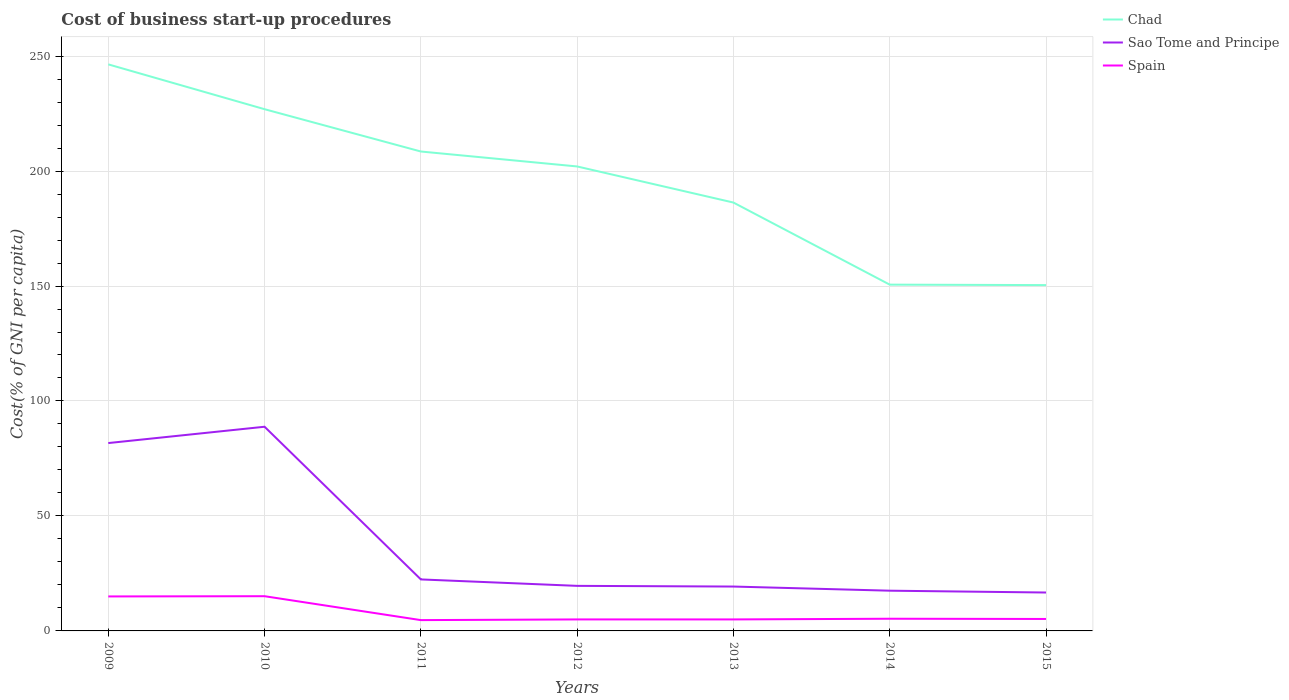What is the total cost of business start-up procedures in Chad in the graph?
Make the answer very short. 60.1. What is the difference between the highest and the second highest cost of business start-up procedures in Sao Tome and Principe?
Offer a very short reply. 72.1. What is the difference between the highest and the lowest cost of business start-up procedures in Chad?
Give a very brief answer. 4. Is the cost of business start-up procedures in Spain strictly greater than the cost of business start-up procedures in Sao Tome and Principe over the years?
Make the answer very short. Yes. What is the difference between two consecutive major ticks on the Y-axis?
Offer a very short reply. 50. Are the values on the major ticks of Y-axis written in scientific E-notation?
Offer a very short reply. No. Where does the legend appear in the graph?
Ensure brevity in your answer.  Top right. How many legend labels are there?
Provide a succinct answer. 3. How are the legend labels stacked?
Your answer should be very brief. Vertical. What is the title of the graph?
Provide a short and direct response. Cost of business start-up procedures. Does "East Asia (all income levels)" appear as one of the legend labels in the graph?
Offer a terse response. No. What is the label or title of the Y-axis?
Offer a terse response. Cost(% of GNI per capita). What is the Cost(% of GNI per capita) in Chad in 2009?
Make the answer very short. 246.4. What is the Cost(% of GNI per capita) in Sao Tome and Principe in 2009?
Your answer should be compact. 81.7. What is the Cost(% of GNI per capita) of Spain in 2009?
Offer a very short reply. 15. What is the Cost(% of GNI per capita) of Chad in 2010?
Offer a very short reply. 226.9. What is the Cost(% of GNI per capita) of Sao Tome and Principe in 2010?
Give a very brief answer. 88.8. What is the Cost(% of GNI per capita) in Chad in 2011?
Your answer should be very brief. 208.5. What is the Cost(% of GNI per capita) in Sao Tome and Principe in 2011?
Make the answer very short. 22.4. What is the Cost(% of GNI per capita) of Chad in 2012?
Offer a very short reply. 202. What is the Cost(% of GNI per capita) in Sao Tome and Principe in 2012?
Offer a terse response. 19.6. What is the Cost(% of GNI per capita) in Chad in 2013?
Keep it short and to the point. 186.3. What is the Cost(% of GNI per capita) of Sao Tome and Principe in 2013?
Ensure brevity in your answer.  19.3. What is the Cost(% of GNI per capita) in Spain in 2013?
Ensure brevity in your answer.  5. What is the Cost(% of GNI per capita) of Chad in 2014?
Offer a terse response. 150.6. What is the Cost(% of GNI per capita) in Spain in 2014?
Your answer should be very brief. 5.3. What is the Cost(% of GNI per capita) of Chad in 2015?
Your answer should be very brief. 150.4. What is the Cost(% of GNI per capita) in Sao Tome and Principe in 2015?
Offer a terse response. 16.7. Across all years, what is the maximum Cost(% of GNI per capita) in Chad?
Make the answer very short. 246.4. Across all years, what is the maximum Cost(% of GNI per capita) in Sao Tome and Principe?
Keep it short and to the point. 88.8. Across all years, what is the maximum Cost(% of GNI per capita) in Spain?
Offer a terse response. 15.1. Across all years, what is the minimum Cost(% of GNI per capita) in Chad?
Keep it short and to the point. 150.4. Across all years, what is the minimum Cost(% of GNI per capita) of Spain?
Keep it short and to the point. 4.7. What is the total Cost(% of GNI per capita) in Chad in the graph?
Provide a succinct answer. 1371.1. What is the total Cost(% of GNI per capita) in Sao Tome and Principe in the graph?
Make the answer very short. 266. What is the total Cost(% of GNI per capita) of Spain in the graph?
Give a very brief answer. 55.3. What is the difference between the Cost(% of GNI per capita) in Chad in 2009 and that in 2010?
Your answer should be compact. 19.5. What is the difference between the Cost(% of GNI per capita) of Sao Tome and Principe in 2009 and that in 2010?
Your response must be concise. -7.1. What is the difference between the Cost(% of GNI per capita) of Spain in 2009 and that in 2010?
Offer a very short reply. -0.1. What is the difference between the Cost(% of GNI per capita) of Chad in 2009 and that in 2011?
Your answer should be very brief. 37.9. What is the difference between the Cost(% of GNI per capita) in Sao Tome and Principe in 2009 and that in 2011?
Give a very brief answer. 59.3. What is the difference between the Cost(% of GNI per capita) of Spain in 2009 and that in 2011?
Ensure brevity in your answer.  10.3. What is the difference between the Cost(% of GNI per capita) of Chad in 2009 and that in 2012?
Provide a succinct answer. 44.4. What is the difference between the Cost(% of GNI per capita) in Sao Tome and Principe in 2009 and that in 2012?
Your response must be concise. 62.1. What is the difference between the Cost(% of GNI per capita) in Chad in 2009 and that in 2013?
Your answer should be very brief. 60.1. What is the difference between the Cost(% of GNI per capita) in Sao Tome and Principe in 2009 and that in 2013?
Offer a very short reply. 62.4. What is the difference between the Cost(% of GNI per capita) of Chad in 2009 and that in 2014?
Provide a short and direct response. 95.8. What is the difference between the Cost(% of GNI per capita) of Sao Tome and Principe in 2009 and that in 2014?
Your response must be concise. 64.2. What is the difference between the Cost(% of GNI per capita) of Chad in 2009 and that in 2015?
Offer a very short reply. 96. What is the difference between the Cost(% of GNI per capita) of Chad in 2010 and that in 2011?
Keep it short and to the point. 18.4. What is the difference between the Cost(% of GNI per capita) in Sao Tome and Principe in 2010 and that in 2011?
Give a very brief answer. 66.4. What is the difference between the Cost(% of GNI per capita) in Spain in 2010 and that in 2011?
Your response must be concise. 10.4. What is the difference between the Cost(% of GNI per capita) of Chad in 2010 and that in 2012?
Your answer should be compact. 24.9. What is the difference between the Cost(% of GNI per capita) in Sao Tome and Principe in 2010 and that in 2012?
Offer a terse response. 69.2. What is the difference between the Cost(% of GNI per capita) in Spain in 2010 and that in 2012?
Provide a short and direct response. 10.1. What is the difference between the Cost(% of GNI per capita) in Chad in 2010 and that in 2013?
Give a very brief answer. 40.6. What is the difference between the Cost(% of GNI per capita) of Sao Tome and Principe in 2010 and that in 2013?
Offer a terse response. 69.5. What is the difference between the Cost(% of GNI per capita) of Spain in 2010 and that in 2013?
Give a very brief answer. 10.1. What is the difference between the Cost(% of GNI per capita) of Chad in 2010 and that in 2014?
Offer a very short reply. 76.3. What is the difference between the Cost(% of GNI per capita) in Sao Tome and Principe in 2010 and that in 2014?
Provide a succinct answer. 71.3. What is the difference between the Cost(% of GNI per capita) of Chad in 2010 and that in 2015?
Your response must be concise. 76.5. What is the difference between the Cost(% of GNI per capita) in Sao Tome and Principe in 2010 and that in 2015?
Give a very brief answer. 72.1. What is the difference between the Cost(% of GNI per capita) in Spain in 2011 and that in 2012?
Your answer should be compact. -0.3. What is the difference between the Cost(% of GNI per capita) of Sao Tome and Principe in 2011 and that in 2013?
Offer a very short reply. 3.1. What is the difference between the Cost(% of GNI per capita) in Spain in 2011 and that in 2013?
Make the answer very short. -0.3. What is the difference between the Cost(% of GNI per capita) in Chad in 2011 and that in 2014?
Offer a very short reply. 57.9. What is the difference between the Cost(% of GNI per capita) of Spain in 2011 and that in 2014?
Provide a succinct answer. -0.6. What is the difference between the Cost(% of GNI per capita) in Chad in 2011 and that in 2015?
Ensure brevity in your answer.  58.1. What is the difference between the Cost(% of GNI per capita) of Sao Tome and Principe in 2011 and that in 2015?
Offer a terse response. 5.7. What is the difference between the Cost(% of GNI per capita) in Spain in 2011 and that in 2015?
Give a very brief answer. -0.5. What is the difference between the Cost(% of GNI per capita) in Spain in 2012 and that in 2013?
Offer a very short reply. 0. What is the difference between the Cost(% of GNI per capita) in Chad in 2012 and that in 2014?
Provide a short and direct response. 51.4. What is the difference between the Cost(% of GNI per capita) in Sao Tome and Principe in 2012 and that in 2014?
Provide a succinct answer. 2.1. What is the difference between the Cost(% of GNI per capita) in Spain in 2012 and that in 2014?
Give a very brief answer. -0.3. What is the difference between the Cost(% of GNI per capita) of Chad in 2012 and that in 2015?
Your response must be concise. 51.6. What is the difference between the Cost(% of GNI per capita) in Sao Tome and Principe in 2012 and that in 2015?
Make the answer very short. 2.9. What is the difference between the Cost(% of GNI per capita) in Spain in 2012 and that in 2015?
Ensure brevity in your answer.  -0.2. What is the difference between the Cost(% of GNI per capita) of Chad in 2013 and that in 2014?
Your response must be concise. 35.7. What is the difference between the Cost(% of GNI per capita) in Sao Tome and Principe in 2013 and that in 2014?
Keep it short and to the point. 1.8. What is the difference between the Cost(% of GNI per capita) in Spain in 2013 and that in 2014?
Keep it short and to the point. -0.3. What is the difference between the Cost(% of GNI per capita) of Chad in 2013 and that in 2015?
Your answer should be very brief. 35.9. What is the difference between the Cost(% of GNI per capita) of Sao Tome and Principe in 2013 and that in 2015?
Offer a terse response. 2.6. What is the difference between the Cost(% of GNI per capita) in Spain in 2013 and that in 2015?
Your answer should be compact. -0.2. What is the difference between the Cost(% of GNI per capita) in Spain in 2014 and that in 2015?
Your response must be concise. 0.1. What is the difference between the Cost(% of GNI per capita) in Chad in 2009 and the Cost(% of GNI per capita) in Sao Tome and Principe in 2010?
Your response must be concise. 157.6. What is the difference between the Cost(% of GNI per capita) of Chad in 2009 and the Cost(% of GNI per capita) of Spain in 2010?
Ensure brevity in your answer.  231.3. What is the difference between the Cost(% of GNI per capita) of Sao Tome and Principe in 2009 and the Cost(% of GNI per capita) of Spain in 2010?
Give a very brief answer. 66.6. What is the difference between the Cost(% of GNI per capita) of Chad in 2009 and the Cost(% of GNI per capita) of Sao Tome and Principe in 2011?
Your answer should be very brief. 224. What is the difference between the Cost(% of GNI per capita) in Chad in 2009 and the Cost(% of GNI per capita) in Spain in 2011?
Ensure brevity in your answer.  241.7. What is the difference between the Cost(% of GNI per capita) in Chad in 2009 and the Cost(% of GNI per capita) in Sao Tome and Principe in 2012?
Your answer should be compact. 226.8. What is the difference between the Cost(% of GNI per capita) of Chad in 2009 and the Cost(% of GNI per capita) of Spain in 2012?
Provide a short and direct response. 241.4. What is the difference between the Cost(% of GNI per capita) of Sao Tome and Principe in 2009 and the Cost(% of GNI per capita) of Spain in 2012?
Offer a terse response. 76.7. What is the difference between the Cost(% of GNI per capita) in Chad in 2009 and the Cost(% of GNI per capita) in Sao Tome and Principe in 2013?
Make the answer very short. 227.1. What is the difference between the Cost(% of GNI per capita) of Chad in 2009 and the Cost(% of GNI per capita) of Spain in 2013?
Your response must be concise. 241.4. What is the difference between the Cost(% of GNI per capita) of Sao Tome and Principe in 2009 and the Cost(% of GNI per capita) of Spain in 2013?
Provide a short and direct response. 76.7. What is the difference between the Cost(% of GNI per capita) in Chad in 2009 and the Cost(% of GNI per capita) in Sao Tome and Principe in 2014?
Ensure brevity in your answer.  228.9. What is the difference between the Cost(% of GNI per capita) in Chad in 2009 and the Cost(% of GNI per capita) in Spain in 2014?
Offer a terse response. 241.1. What is the difference between the Cost(% of GNI per capita) of Sao Tome and Principe in 2009 and the Cost(% of GNI per capita) of Spain in 2014?
Provide a succinct answer. 76.4. What is the difference between the Cost(% of GNI per capita) of Chad in 2009 and the Cost(% of GNI per capita) of Sao Tome and Principe in 2015?
Your answer should be very brief. 229.7. What is the difference between the Cost(% of GNI per capita) of Chad in 2009 and the Cost(% of GNI per capita) of Spain in 2015?
Your response must be concise. 241.2. What is the difference between the Cost(% of GNI per capita) of Sao Tome and Principe in 2009 and the Cost(% of GNI per capita) of Spain in 2015?
Ensure brevity in your answer.  76.5. What is the difference between the Cost(% of GNI per capita) of Chad in 2010 and the Cost(% of GNI per capita) of Sao Tome and Principe in 2011?
Your answer should be very brief. 204.5. What is the difference between the Cost(% of GNI per capita) of Chad in 2010 and the Cost(% of GNI per capita) of Spain in 2011?
Keep it short and to the point. 222.2. What is the difference between the Cost(% of GNI per capita) in Sao Tome and Principe in 2010 and the Cost(% of GNI per capita) in Spain in 2011?
Your answer should be compact. 84.1. What is the difference between the Cost(% of GNI per capita) of Chad in 2010 and the Cost(% of GNI per capita) of Sao Tome and Principe in 2012?
Ensure brevity in your answer.  207.3. What is the difference between the Cost(% of GNI per capita) in Chad in 2010 and the Cost(% of GNI per capita) in Spain in 2012?
Your response must be concise. 221.9. What is the difference between the Cost(% of GNI per capita) in Sao Tome and Principe in 2010 and the Cost(% of GNI per capita) in Spain in 2012?
Provide a short and direct response. 83.8. What is the difference between the Cost(% of GNI per capita) in Chad in 2010 and the Cost(% of GNI per capita) in Sao Tome and Principe in 2013?
Your answer should be very brief. 207.6. What is the difference between the Cost(% of GNI per capita) in Chad in 2010 and the Cost(% of GNI per capita) in Spain in 2013?
Provide a short and direct response. 221.9. What is the difference between the Cost(% of GNI per capita) in Sao Tome and Principe in 2010 and the Cost(% of GNI per capita) in Spain in 2013?
Make the answer very short. 83.8. What is the difference between the Cost(% of GNI per capita) of Chad in 2010 and the Cost(% of GNI per capita) of Sao Tome and Principe in 2014?
Offer a terse response. 209.4. What is the difference between the Cost(% of GNI per capita) in Chad in 2010 and the Cost(% of GNI per capita) in Spain in 2014?
Offer a very short reply. 221.6. What is the difference between the Cost(% of GNI per capita) in Sao Tome and Principe in 2010 and the Cost(% of GNI per capita) in Spain in 2014?
Give a very brief answer. 83.5. What is the difference between the Cost(% of GNI per capita) of Chad in 2010 and the Cost(% of GNI per capita) of Sao Tome and Principe in 2015?
Provide a succinct answer. 210.2. What is the difference between the Cost(% of GNI per capita) in Chad in 2010 and the Cost(% of GNI per capita) in Spain in 2015?
Make the answer very short. 221.7. What is the difference between the Cost(% of GNI per capita) of Sao Tome and Principe in 2010 and the Cost(% of GNI per capita) of Spain in 2015?
Give a very brief answer. 83.6. What is the difference between the Cost(% of GNI per capita) of Chad in 2011 and the Cost(% of GNI per capita) of Sao Tome and Principe in 2012?
Give a very brief answer. 188.9. What is the difference between the Cost(% of GNI per capita) of Chad in 2011 and the Cost(% of GNI per capita) of Spain in 2012?
Give a very brief answer. 203.5. What is the difference between the Cost(% of GNI per capita) in Chad in 2011 and the Cost(% of GNI per capita) in Sao Tome and Principe in 2013?
Provide a succinct answer. 189.2. What is the difference between the Cost(% of GNI per capita) of Chad in 2011 and the Cost(% of GNI per capita) of Spain in 2013?
Make the answer very short. 203.5. What is the difference between the Cost(% of GNI per capita) in Chad in 2011 and the Cost(% of GNI per capita) in Sao Tome and Principe in 2014?
Provide a succinct answer. 191. What is the difference between the Cost(% of GNI per capita) of Chad in 2011 and the Cost(% of GNI per capita) of Spain in 2014?
Give a very brief answer. 203.2. What is the difference between the Cost(% of GNI per capita) in Chad in 2011 and the Cost(% of GNI per capita) in Sao Tome and Principe in 2015?
Your answer should be very brief. 191.8. What is the difference between the Cost(% of GNI per capita) of Chad in 2011 and the Cost(% of GNI per capita) of Spain in 2015?
Make the answer very short. 203.3. What is the difference between the Cost(% of GNI per capita) of Sao Tome and Principe in 2011 and the Cost(% of GNI per capita) of Spain in 2015?
Provide a short and direct response. 17.2. What is the difference between the Cost(% of GNI per capita) in Chad in 2012 and the Cost(% of GNI per capita) in Sao Tome and Principe in 2013?
Make the answer very short. 182.7. What is the difference between the Cost(% of GNI per capita) of Chad in 2012 and the Cost(% of GNI per capita) of Spain in 2013?
Your answer should be compact. 197. What is the difference between the Cost(% of GNI per capita) in Sao Tome and Principe in 2012 and the Cost(% of GNI per capita) in Spain in 2013?
Keep it short and to the point. 14.6. What is the difference between the Cost(% of GNI per capita) in Chad in 2012 and the Cost(% of GNI per capita) in Sao Tome and Principe in 2014?
Offer a very short reply. 184.5. What is the difference between the Cost(% of GNI per capita) of Chad in 2012 and the Cost(% of GNI per capita) of Spain in 2014?
Provide a short and direct response. 196.7. What is the difference between the Cost(% of GNI per capita) of Sao Tome and Principe in 2012 and the Cost(% of GNI per capita) of Spain in 2014?
Your response must be concise. 14.3. What is the difference between the Cost(% of GNI per capita) of Chad in 2012 and the Cost(% of GNI per capita) of Sao Tome and Principe in 2015?
Your response must be concise. 185.3. What is the difference between the Cost(% of GNI per capita) in Chad in 2012 and the Cost(% of GNI per capita) in Spain in 2015?
Ensure brevity in your answer.  196.8. What is the difference between the Cost(% of GNI per capita) in Sao Tome and Principe in 2012 and the Cost(% of GNI per capita) in Spain in 2015?
Keep it short and to the point. 14.4. What is the difference between the Cost(% of GNI per capita) in Chad in 2013 and the Cost(% of GNI per capita) in Sao Tome and Principe in 2014?
Your answer should be very brief. 168.8. What is the difference between the Cost(% of GNI per capita) of Chad in 2013 and the Cost(% of GNI per capita) of Spain in 2014?
Offer a terse response. 181. What is the difference between the Cost(% of GNI per capita) of Sao Tome and Principe in 2013 and the Cost(% of GNI per capita) of Spain in 2014?
Provide a succinct answer. 14. What is the difference between the Cost(% of GNI per capita) of Chad in 2013 and the Cost(% of GNI per capita) of Sao Tome and Principe in 2015?
Your answer should be very brief. 169.6. What is the difference between the Cost(% of GNI per capita) in Chad in 2013 and the Cost(% of GNI per capita) in Spain in 2015?
Keep it short and to the point. 181.1. What is the difference between the Cost(% of GNI per capita) of Chad in 2014 and the Cost(% of GNI per capita) of Sao Tome and Principe in 2015?
Offer a very short reply. 133.9. What is the difference between the Cost(% of GNI per capita) in Chad in 2014 and the Cost(% of GNI per capita) in Spain in 2015?
Provide a short and direct response. 145.4. What is the difference between the Cost(% of GNI per capita) of Sao Tome and Principe in 2014 and the Cost(% of GNI per capita) of Spain in 2015?
Provide a succinct answer. 12.3. What is the average Cost(% of GNI per capita) in Chad per year?
Keep it short and to the point. 195.87. What is the average Cost(% of GNI per capita) in Sao Tome and Principe per year?
Make the answer very short. 38. In the year 2009, what is the difference between the Cost(% of GNI per capita) of Chad and Cost(% of GNI per capita) of Sao Tome and Principe?
Make the answer very short. 164.7. In the year 2009, what is the difference between the Cost(% of GNI per capita) in Chad and Cost(% of GNI per capita) in Spain?
Offer a very short reply. 231.4. In the year 2009, what is the difference between the Cost(% of GNI per capita) of Sao Tome and Principe and Cost(% of GNI per capita) of Spain?
Offer a terse response. 66.7. In the year 2010, what is the difference between the Cost(% of GNI per capita) in Chad and Cost(% of GNI per capita) in Sao Tome and Principe?
Your answer should be very brief. 138.1. In the year 2010, what is the difference between the Cost(% of GNI per capita) in Chad and Cost(% of GNI per capita) in Spain?
Provide a succinct answer. 211.8. In the year 2010, what is the difference between the Cost(% of GNI per capita) of Sao Tome and Principe and Cost(% of GNI per capita) of Spain?
Ensure brevity in your answer.  73.7. In the year 2011, what is the difference between the Cost(% of GNI per capita) of Chad and Cost(% of GNI per capita) of Sao Tome and Principe?
Your response must be concise. 186.1. In the year 2011, what is the difference between the Cost(% of GNI per capita) of Chad and Cost(% of GNI per capita) of Spain?
Your response must be concise. 203.8. In the year 2011, what is the difference between the Cost(% of GNI per capita) in Sao Tome and Principe and Cost(% of GNI per capita) in Spain?
Ensure brevity in your answer.  17.7. In the year 2012, what is the difference between the Cost(% of GNI per capita) of Chad and Cost(% of GNI per capita) of Sao Tome and Principe?
Give a very brief answer. 182.4. In the year 2012, what is the difference between the Cost(% of GNI per capita) in Chad and Cost(% of GNI per capita) in Spain?
Your answer should be very brief. 197. In the year 2012, what is the difference between the Cost(% of GNI per capita) in Sao Tome and Principe and Cost(% of GNI per capita) in Spain?
Offer a terse response. 14.6. In the year 2013, what is the difference between the Cost(% of GNI per capita) in Chad and Cost(% of GNI per capita) in Sao Tome and Principe?
Offer a terse response. 167. In the year 2013, what is the difference between the Cost(% of GNI per capita) of Chad and Cost(% of GNI per capita) of Spain?
Offer a terse response. 181.3. In the year 2013, what is the difference between the Cost(% of GNI per capita) of Sao Tome and Principe and Cost(% of GNI per capita) of Spain?
Offer a very short reply. 14.3. In the year 2014, what is the difference between the Cost(% of GNI per capita) in Chad and Cost(% of GNI per capita) in Sao Tome and Principe?
Provide a short and direct response. 133.1. In the year 2014, what is the difference between the Cost(% of GNI per capita) in Chad and Cost(% of GNI per capita) in Spain?
Ensure brevity in your answer.  145.3. In the year 2015, what is the difference between the Cost(% of GNI per capita) of Chad and Cost(% of GNI per capita) of Sao Tome and Principe?
Provide a succinct answer. 133.7. In the year 2015, what is the difference between the Cost(% of GNI per capita) in Chad and Cost(% of GNI per capita) in Spain?
Give a very brief answer. 145.2. In the year 2015, what is the difference between the Cost(% of GNI per capita) in Sao Tome and Principe and Cost(% of GNI per capita) in Spain?
Offer a terse response. 11.5. What is the ratio of the Cost(% of GNI per capita) in Chad in 2009 to that in 2010?
Ensure brevity in your answer.  1.09. What is the ratio of the Cost(% of GNI per capita) of Chad in 2009 to that in 2011?
Keep it short and to the point. 1.18. What is the ratio of the Cost(% of GNI per capita) of Sao Tome and Principe in 2009 to that in 2011?
Your answer should be compact. 3.65. What is the ratio of the Cost(% of GNI per capita) in Spain in 2009 to that in 2011?
Provide a short and direct response. 3.19. What is the ratio of the Cost(% of GNI per capita) of Chad in 2009 to that in 2012?
Offer a very short reply. 1.22. What is the ratio of the Cost(% of GNI per capita) of Sao Tome and Principe in 2009 to that in 2012?
Provide a short and direct response. 4.17. What is the ratio of the Cost(% of GNI per capita) of Spain in 2009 to that in 2012?
Offer a very short reply. 3. What is the ratio of the Cost(% of GNI per capita) of Chad in 2009 to that in 2013?
Provide a short and direct response. 1.32. What is the ratio of the Cost(% of GNI per capita) in Sao Tome and Principe in 2009 to that in 2013?
Offer a very short reply. 4.23. What is the ratio of the Cost(% of GNI per capita) in Chad in 2009 to that in 2014?
Your answer should be very brief. 1.64. What is the ratio of the Cost(% of GNI per capita) in Sao Tome and Principe in 2009 to that in 2014?
Keep it short and to the point. 4.67. What is the ratio of the Cost(% of GNI per capita) in Spain in 2009 to that in 2014?
Your answer should be very brief. 2.83. What is the ratio of the Cost(% of GNI per capita) in Chad in 2009 to that in 2015?
Your answer should be compact. 1.64. What is the ratio of the Cost(% of GNI per capita) in Sao Tome and Principe in 2009 to that in 2015?
Give a very brief answer. 4.89. What is the ratio of the Cost(% of GNI per capita) in Spain in 2009 to that in 2015?
Your response must be concise. 2.88. What is the ratio of the Cost(% of GNI per capita) of Chad in 2010 to that in 2011?
Offer a terse response. 1.09. What is the ratio of the Cost(% of GNI per capita) in Sao Tome and Principe in 2010 to that in 2011?
Keep it short and to the point. 3.96. What is the ratio of the Cost(% of GNI per capita) in Spain in 2010 to that in 2011?
Your answer should be very brief. 3.21. What is the ratio of the Cost(% of GNI per capita) in Chad in 2010 to that in 2012?
Keep it short and to the point. 1.12. What is the ratio of the Cost(% of GNI per capita) in Sao Tome and Principe in 2010 to that in 2012?
Offer a very short reply. 4.53. What is the ratio of the Cost(% of GNI per capita) in Spain in 2010 to that in 2012?
Offer a very short reply. 3.02. What is the ratio of the Cost(% of GNI per capita) in Chad in 2010 to that in 2013?
Offer a terse response. 1.22. What is the ratio of the Cost(% of GNI per capita) of Sao Tome and Principe in 2010 to that in 2013?
Provide a succinct answer. 4.6. What is the ratio of the Cost(% of GNI per capita) of Spain in 2010 to that in 2013?
Give a very brief answer. 3.02. What is the ratio of the Cost(% of GNI per capita) of Chad in 2010 to that in 2014?
Your answer should be very brief. 1.51. What is the ratio of the Cost(% of GNI per capita) of Sao Tome and Principe in 2010 to that in 2014?
Provide a succinct answer. 5.07. What is the ratio of the Cost(% of GNI per capita) in Spain in 2010 to that in 2014?
Offer a terse response. 2.85. What is the ratio of the Cost(% of GNI per capita) of Chad in 2010 to that in 2015?
Your response must be concise. 1.51. What is the ratio of the Cost(% of GNI per capita) in Sao Tome and Principe in 2010 to that in 2015?
Make the answer very short. 5.32. What is the ratio of the Cost(% of GNI per capita) of Spain in 2010 to that in 2015?
Your response must be concise. 2.9. What is the ratio of the Cost(% of GNI per capita) in Chad in 2011 to that in 2012?
Make the answer very short. 1.03. What is the ratio of the Cost(% of GNI per capita) of Sao Tome and Principe in 2011 to that in 2012?
Make the answer very short. 1.14. What is the ratio of the Cost(% of GNI per capita) in Chad in 2011 to that in 2013?
Give a very brief answer. 1.12. What is the ratio of the Cost(% of GNI per capita) in Sao Tome and Principe in 2011 to that in 2013?
Your response must be concise. 1.16. What is the ratio of the Cost(% of GNI per capita) of Chad in 2011 to that in 2014?
Provide a short and direct response. 1.38. What is the ratio of the Cost(% of GNI per capita) of Sao Tome and Principe in 2011 to that in 2014?
Make the answer very short. 1.28. What is the ratio of the Cost(% of GNI per capita) in Spain in 2011 to that in 2014?
Your response must be concise. 0.89. What is the ratio of the Cost(% of GNI per capita) in Chad in 2011 to that in 2015?
Give a very brief answer. 1.39. What is the ratio of the Cost(% of GNI per capita) in Sao Tome and Principe in 2011 to that in 2015?
Your response must be concise. 1.34. What is the ratio of the Cost(% of GNI per capita) in Spain in 2011 to that in 2015?
Your response must be concise. 0.9. What is the ratio of the Cost(% of GNI per capita) of Chad in 2012 to that in 2013?
Your answer should be very brief. 1.08. What is the ratio of the Cost(% of GNI per capita) of Sao Tome and Principe in 2012 to that in 2013?
Keep it short and to the point. 1.02. What is the ratio of the Cost(% of GNI per capita) of Spain in 2012 to that in 2013?
Your answer should be compact. 1. What is the ratio of the Cost(% of GNI per capita) of Chad in 2012 to that in 2014?
Your response must be concise. 1.34. What is the ratio of the Cost(% of GNI per capita) in Sao Tome and Principe in 2012 to that in 2014?
Offer a very short reply. 1.12. What is the ratio of the Cost(% of GNI per capita) in Spain in 2012 to that in 2014?
Offer a terse response. 0.94. What is the ratio of the Cost(% of GNI per capita) of Chad in 2012 to that in 2015?
Make the answer very short. 1.34. What is the ratio of the Cost(% of GNI per capita) of Sao Tome and Principe in 2012 to that in 2015?
Make the answer very short. 1.17. What is the ratio of the Cost(% of GNI per capita) of Spain in 2012 to that in 2015?
Provide a short and direct response. 0.96. What is the ratio of the Cost(% of GNI per capita) of Chad in 2013 to that in 2014?
Keep it short and to the point. 1.24. What is the ratio of the Cost(% of GNI per capita) in Sao Tome and Principe in 2013 to that in 2014?
Give a very brief answer. 1.1. What is the ratio of the Cost(% of GNI per capita) in Spain in 2013 to that in 2014?
Offer a very short reply. 0.94. What is the ratio of the Cost(% of GNI per capita) of Chad in 2013 to that in 2015?
Provide a succinct answer. 1.24. What is the ratio of the Cost(% of GNI per capita) of Sao Tome and Principe in 2013 to that in 2015?
Offer a very short reply. 1.16. What is the ratio of the Cost(% of GNI per capita) in Spain in 2013 to that in 2015?
Give a very brief answer. 0.96. What is the ratio of the Cost(% of GNI per capita) of Sao Tome and Principe in 2014 to that in 2015?
Keep it short and to the point. 1.05. What is the ratio of the Cost(% of GNI per capita) in Spain in 2014 to that in 2015?
Ensure brevity in your answer.  1.02. What is the difference between the highest and the second highest Cost(% of GNI per capita) in Chad?
Offer a terse response. 19.5. What is the difference between the highest and the second highest Cost(% of GNI per capita) of Spain?
Your response must be concise. 0.1. What is the difference between the highest and the lowest Cost(% of GNI per capita) in Chad?
Your answer should be very brief. 96. What is the difference between the highest and the lowest Cost(% of GNI per capita) of Sao Tome and Principe?
Make the answer very short. 72.1. What is the difference between the highest and the lowest Cost(% of GNI per capita) in Spain?
Your answer should be compact. 10.4. 